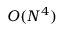<formula> <loc_0><loc_0><loc_500><loc_500>O ( N ^ { 4 } )</formula> 